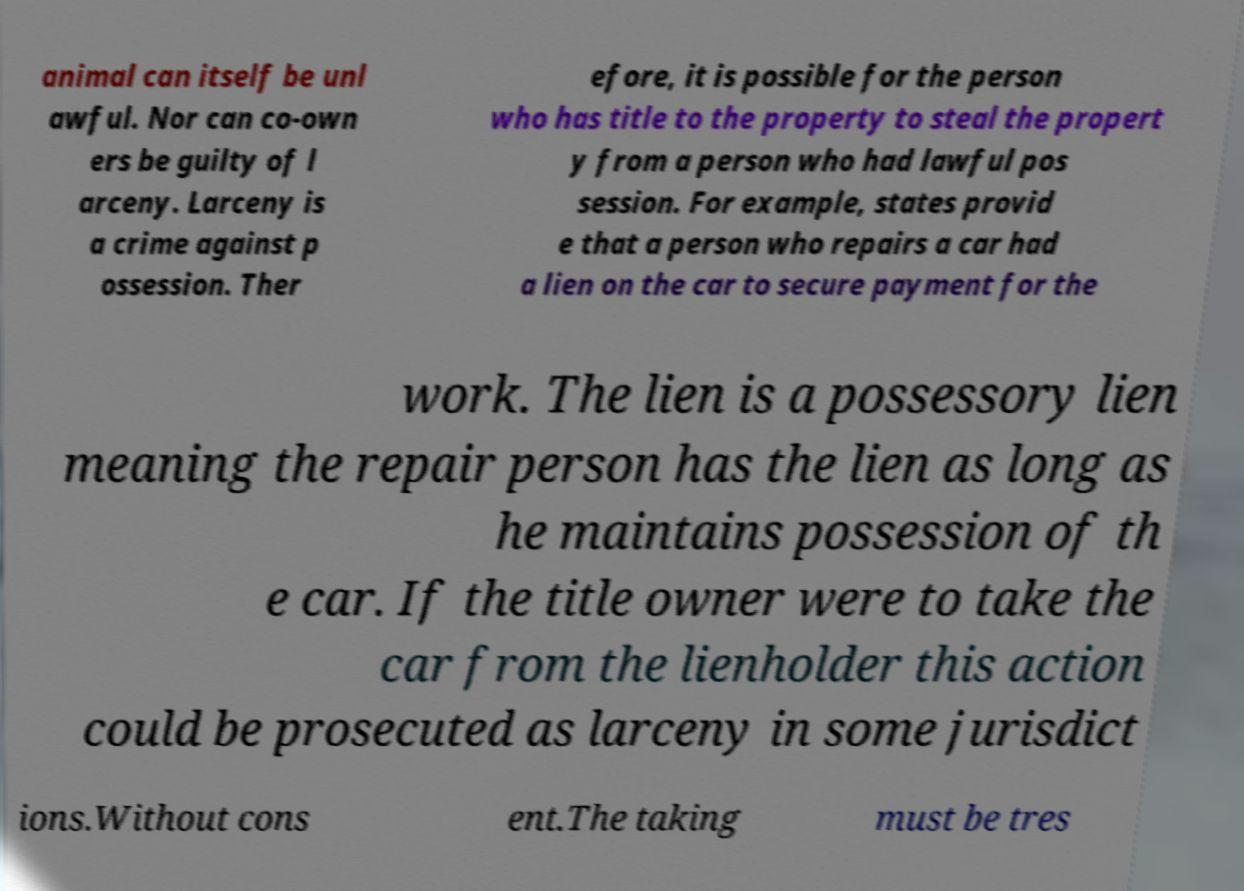What messages or text are displayed in this image? I need them in a readable, typed format. animal can itself be unl awful. Nor can co-own ers be guilty of l arceny. Larceny is a crime against p ossession. Ther efore, it is possible for the person who has title to the property to steal the propert y from a person who had lawful pos session. For example, states provid e that a person who repairs a car had a lien on the car to secure payment for the work. The lien is a possessory lien meaning the repair person has the lien as long as he maintains possession of th e car. If the title owner were to take the car from the lienholder this action could be prosecuted as larceny in some jurisdict ions.Without cons ent.The taking must be tres 